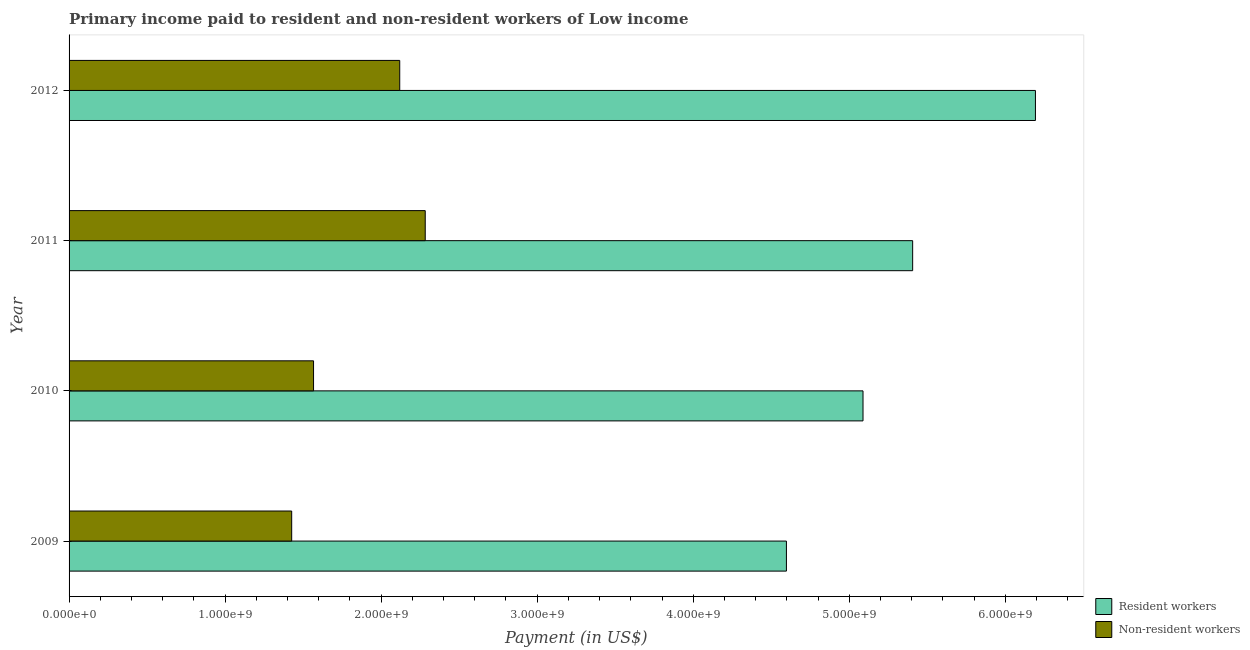How many different coloured bars are there?
Your answer should be very brief. 2. Are the number of bars on each tick of the Y-axis equal?
Provide a succinct answer. Yes. How many bars are there on the 1st tick from the bottom?
Keep it short and to the point. 2. What is the label of the 3rd group of bars from the top?
Make the answer very short. 2010. What is the payment made to non-resident workers in 2012?
Offer a terse response. 2.12e+09. Across all years, what is the maximum payment made to resident workers?
Ensure brevity in your answer.  6.19e+09. Across all years, what is the minimum payment made to non-resident workers?
Your response must be concise. 1.43e+09. In which year was the payment made to resident workers maximum?
Your response must be concise. 2012. In which year was the payment made to resident workers minimum?
Provide a succinct answer. 2009. What is the total payment made to non-resident workers in the graph?
Your response must be concise. 7.40e+09. What is the difference between the payment made to resident workers in 2010 and that in 2011?
Provide a succinct answer. -3.18e+08. What is the difference between the payment made to non-resident workers in 2010 and the payment made to resident workers in 2012?
Provide a short and direct response. -4.63e+09. What is the average payment made to resident workers per year?
Keep it short and to the point. 5.32e+09. In the year 2011, what is the difference between the payment made to non-resident workers and payment made to resident workers?
Your response must be concise. -3.12e+09. In how many years, is the payment made to resident workers greater than 400000000 US$?
Give a very brief answer. 4. What is the ratio of the payment made to resident workers in 2011 to that in 2012?
Make the answer very short. 0.87. What is the difference between the highest and the second highest payment made to resident workers?
Offer a very short reply. 7.87e+08. What is the difference between the highest and the lowest payment made to non-resident workers?
Make the answer very short. 8.56e+08. In how many years, is the payment made to resident workers greater than the average payment made to resident workers taken over all years?
Make the answer very short. 2. Is the sum of the payment made to non-resident workers in 2010 and 2011 greater than the maximum payment made to resident workers across all years?
Give a very brief answer. No. What does the 1st bar from the top in 2010 represents?
Provide a succinct answer. Non-resident workers. What does the 2nd bar from the bottom in 2010 represents?
Keep it short and to the point. Non-resident workers. How many bars are there?
Give a very brief answer. 8. How many years are there in the graph?
Make the answer very short. 4. What is the difference between two consecutive major ticks on the X-axis?
Give a very brief answer. 1.00e+09. Are the values on the major ticks of X-axis written in scientific E-notation?
Ensure brevity in your answer.  Yes. Does the graph contain grids?
Your answer should be compact. No. Where does the legend appear in the graph?
Offer a very short reply. Bottom right. What is the title of the graph?
Ensure brevity in your answer.  Primary income paid to resident and non-resident workers of Low income. Does "Nitrous oxide emissions" appear as one of the legend labels in the graph?
Provide a short and direct response. No. What is the label or title of the X-axis?
Provide a succinct answer. Payment (in US$). What is the label or title of the Y-axis?
Your response must be concise. Year. What is the Payment (in US$) in Resident workers in 2009?
Ensure brevity in your answer.  4.60e+09. What is the Payment (in US$) of Non-resident workers in 2009?
Your answer should be compact. 1.43e+09. What is the Payment (in US$) of Resident workers in 2010?
Your response must be concise. 5.09e+09. What is the Payment (in US$) in Non-resident workers in 2010?
Provide a succinct answer. 1.57e+09. What is the Payment (in US$) in Resident workers in 2011?
Keep it short and to the point. 5.41e+09. What is the Payment (in US$) of Non-resident workers in 2011?
Keep it short and to the point. 2.28e+09. What is the Payment (in US$) of Resident workers in 2012?
Keep it short and to the point. 6.19e+09. What is the Payment (in US$) of Non-resident workers in 2012?
Give a very brief answer. 2.12e+09. Across all years, what is the maximum Payment (in US$) of Resident workers?
Provide a succinct answer. 6.19e+09. Across all years, what is the maximum Payment (in US$) in Non-resident workers?
Make the answer very short. 2.28e+09. Across all years, what is the minimum Payment (in US$) in Resident workers?
Your answer should be very brief. 4.60e+09. Across all years, what is the minimum Payment (in US$) in Non-resident workers?
Provide a succinct answer. 1.43e+09. What is the total Payment (in US$) of Resident workers in the graph?
Your answer should be very brief. 2.13e+1. What is the total Payment (in US$) in Non-resident workers in the graph?
Offer a terse response. 7.40e+09. What is the difference between the Payment (in US$) in Resident workers in 2009 and that in 2010?
Your response must be concise. -4.91e+08. What is the difference between the Payment (in US$) of Non-resident workers in 2009 and that in 2010?
Provide a succinct answer. -1.40e+08. What is the difference between the Payment (in US$) of Resident workers in 2009 and that in 2011?
Offer a terse response. -8.09e+08. What is the difference between the Payment (in US$) of Non-resident workers in 2009 and that in 2011?
Give a very brief answer. -8.56e+08. What is the difference between the Payment (in US$) in Resident workers in 2009 and that in 2012?
Make the answer very short. -1.60e+09. What is the difference between the Payment (in US$) in Non-resident workers in 2009 and that in 2012?
Ensure brevity in your answer.  -6.92e+08. What is the difference between the Payment (in US$) of Resident workers in 2010 and that in 2011?
Offer a terse response. -3.18e+08. What is the difference between the Payment (in US$) of Non-resident workers in 2010 and that in 2011?
Give a very brief answer. -7.16e+08. What is the difference between the Payment (in US$) of Resident workers in 2010 and that in 2012?
Your answer should be very brief. -1.10e+09. What is the difference between the Payment (in US$) of Non-resident workers in 2010 and that in 2012?
Give a very brief answer. -5.52e+08. What is the difference between the Payment (in US$) in Resident workers in 2011 and that in 2012?
Provide a short and direct response. -7.87e+08. What is the difference between the Payment (in US$) in Non-resident workers in 2011 and that in 2012?
Give a very brief answer. 1.63e+08. What is the difference between the Payment (in US$) in Resident workers in 2009 and the Payment (in US$) in Non-resident workers in 2010?
Keep it short and to the point. 3.03e+09. What is the difference between the Payment (in US$) in Resident workers in 2009 and the Payment (in US$) in Non-resident workers in 2011?
Keep it short and to the point. 2.31e+09. What is the difference between the Payment (in US$) of Resident workers in 2009 and the Payment (in US$) of Non-resident workers in 2012?
Provide a succinct answer. 2.48e+09. What is the difference between the Payment (in US$) of Resident workers in 2010 and the Payment (in US$) of Non-resident workers in 2011?
Your answer should be compact. 2.81e+09. What is the difference between the Payment (in US$) in Resident workers in 2010 and the Payment (in US$) in Non-resident workers in 2012?
Make the answer very short. 2.97e+09. What is the difference between the Payment (in US$) of Resident workers in 2011 and the Payment (in US$) of Non-resident workers in 2012?
Ensure brevity in your answer.  3.29e+09. What is the average Payment (in US$) in Resident workers per year?
Provide a succinct answer. 5.32e+09. What is the average Payment (in US$) of Non-resident workers per year?
Your response must be concise. 1.85e+09. In the year 2009, what is the difference between the Payment (in US$) in Resident workers and Payment (in US$) in Non-resident workers?
Your answer should be compact. 3.17e+09. In the year 2010, what is the difference between the Payment (in US$) in Resident workers and Payment (in US$) in Non-resident workers?
Provide a short and direct response. 3.52e+09. In the year 2011, what is the difference between the Payment (in US$) in Resident workers and Payment (in US$) in Non-resident workers?
Provide a short and direct response. 3.12e+09. In the year 2012, what is the difference between the Payment (in US$) of Resident workers and Payment (in US$) of Non-resident workers?
Offer a terse response. 4.07e+09. What is the ratio of the Payment (in US$) of Resident workers in 2009 to that in 2010?
Your response must be concise. 0.9. What is the ratio of the Payment (in US$) of Non-resident workers in 2009 to that in 2010?
Your answer should be very brief. 0.91. What is the ratio of the Payment (in US$) in Resident workers in 2009 to that in 2011?
Your answer should be very brief. 0.85. What is the ratio of the Payment (in US$) in Non-resident workers in 2009 to that in 2011?
Provide a short and direct response. 0.63. What is the ratio of the Payment (in US$) of Resident workers in 2009 to that in 2012?
Give a very brief answer. 0.74. What is the ratio of the Payment (in US$) in Non-resident workers in 2009 to that in 2012?
Keep it short and to the point. 0.67. What is the ratio of the Payment (in US$) of Resident workers in 2010 to that in 2011?
Give a very brief answer. 0.94. What is the ratio of the Payment (in US$) in Non-resident workers in 2010 to that in 2011?
Provide a succinct answer. 0.69. What is the ratio of the Payment (in US$) in Resident workers in 2010 to that in 2012?
Keep it short and to the point. 0.82. What is the ratio of the Payment (in US$) in Non-resident workers in 2010 to that in 2012?
Provide a short and direct response. 0.74. What is the ratio of the Payment (in US$) in Resident workers in 2011 to that in 2012?
Give a very brief answer. 0.87. What is the ratio of the Payment (in US$) of Non-resident workers in 2011 to that in 2012?
Provide a succinct answer. 1.08. What is the difference between the highest and the second highest Payment (in US$) of Resident workers?
Your answer should be very brief. 7.87e+08. What is the difference between the highest and the second highest Payment (in US$) of Non-resident workers?
Provide a short and direct response. 1.63e+08. What is the difference between the highest and the lowest Payment (in US$) in Resident workers?
Give a very brief answer. 1.60e+09. What is the difference between the highest and the lowest Payment (in US$) in Non-resident workers?
Keep it short and to the point. 8.56e+08. 